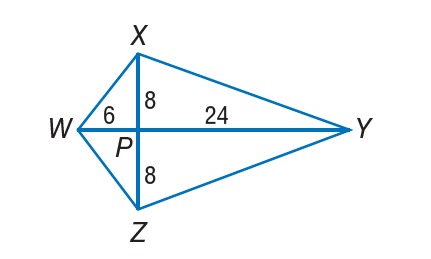Question: If W X Y Z is a kite, find Z Y.
Choices:
A. \sqrt { 10 }
B. 8
C. 16
D. 8 \sqrt { 10 }
Answer with the letter. Answer: D 